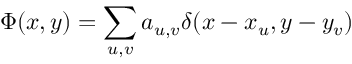Convert formula to latex. <formula><loc_0><loc_0><loc_500><loc_500>\Phi ( x , y ) = \sum _ { u , v } a _ { u , v } \delta ( x - x _ { u } , y - y _ { v } )</formula> 